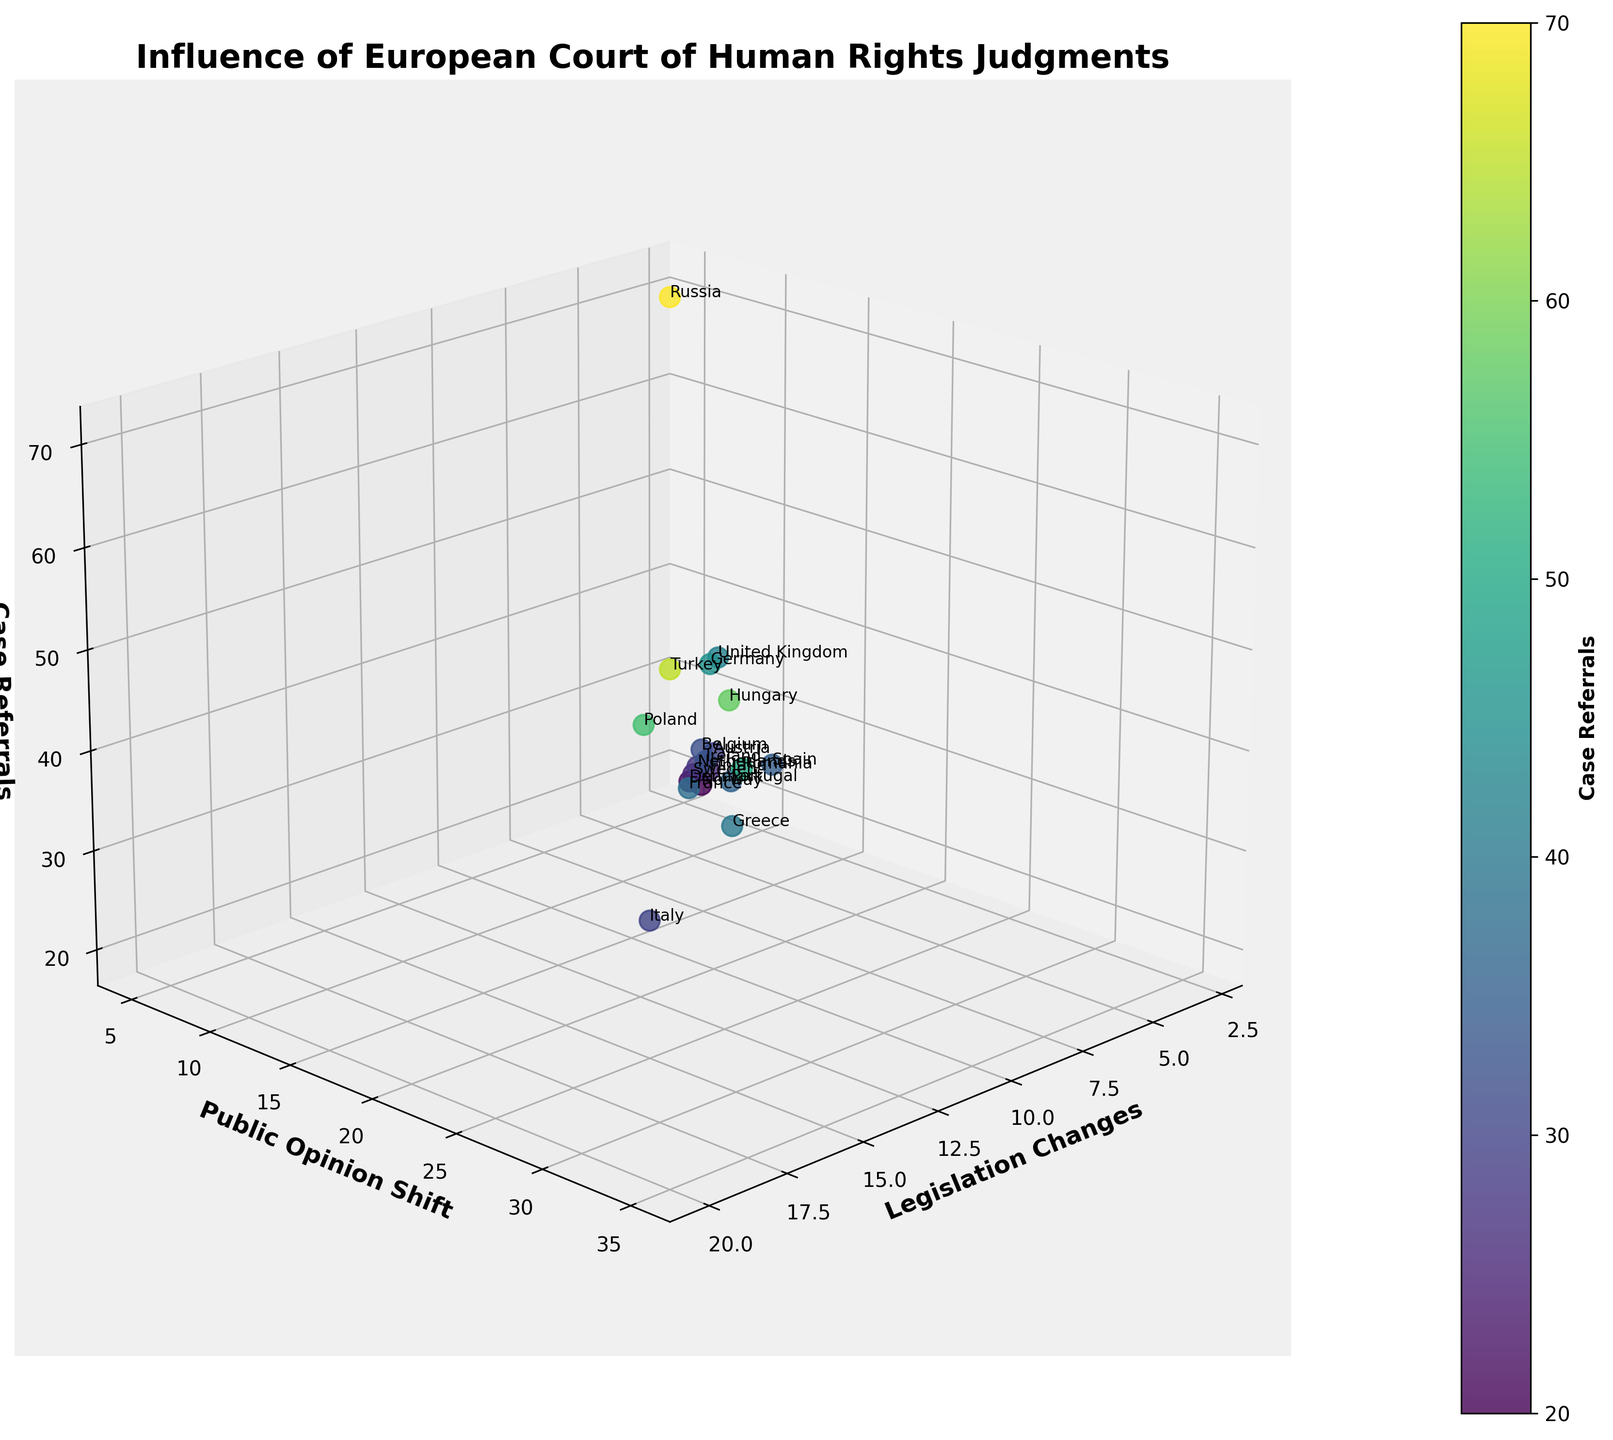Which country shows the highest number of legislation changes? Look at the 'Legislation Changes' axis and identify the country with the highest value. Turkey has the highest value of 20.
Answer: Turkey What is the title of the plot? Look at the top of the plot where the title is usually located. The title is "Influence of European Court of Human Rights Judgments".
Answer: Influence of European Court of Human Rights Judgments Which country has the most significant public opinion shift? Check the 'Public Opinion Shift' axis and find the country with the highest data point. Turkey has the highest value of 35.
Answer: Turkey What are the axis labels of the plot? Observe the labels on each axis. The labels are 'Legislation Changes' for the x-axis, 'Public Opinion Shift' for the y-axis, and 'Case Referrals' for the z-axis.
Answer: Legislation Changes, Public Opinion Shift, Case Referrals Which country has a combination of 9 legislation changes and 18 public opinion shifts? Look for the data point with x=9 and y=18 and check the corresponding country label. This data point corresponds to Germany.
Answer: Germany How does the number of case referrals in France compare to Germany? Identify the 'Case Referrals' value for both countries. France has 38 and Germany has 45. Germany has more case referrals than France.
Answer: Germany has more What is the sum of legislation changes for Italy and Poland? Add the 'Legislation Changes' value for Italy (15) and Poland (18). The sum is 15 + 18 = 33.
Answer: 33 Which two countries have almost the same number of case referrals? Compare the 'Case Referrals' values of countries that are close in value. France (38) and Spain (35) have almost the same number.
Answer: France and Spain What is the median value of public opinion shifts among all countries? Arrange all public opinion shift values in ascending order and find the middle one. The ordered values are [5, 7, 8, 10, 11, 12, 13, 14, 15, 16, 18, 20, 21, 22, 25, 28, 30, 32, 33, 35]. The median value is (16+18)/2 = 17.
Answer: 17 Which country has the lowest legislation changes and how many case referrals do they have? Find the country with the smallest value on the 'Legislation Changes' axis and check the corresponding value on the 'Case Referrals' axis. Russia has the lowest legislation changes (3) and has 70 case referrals.
Answer: Russia, 70 